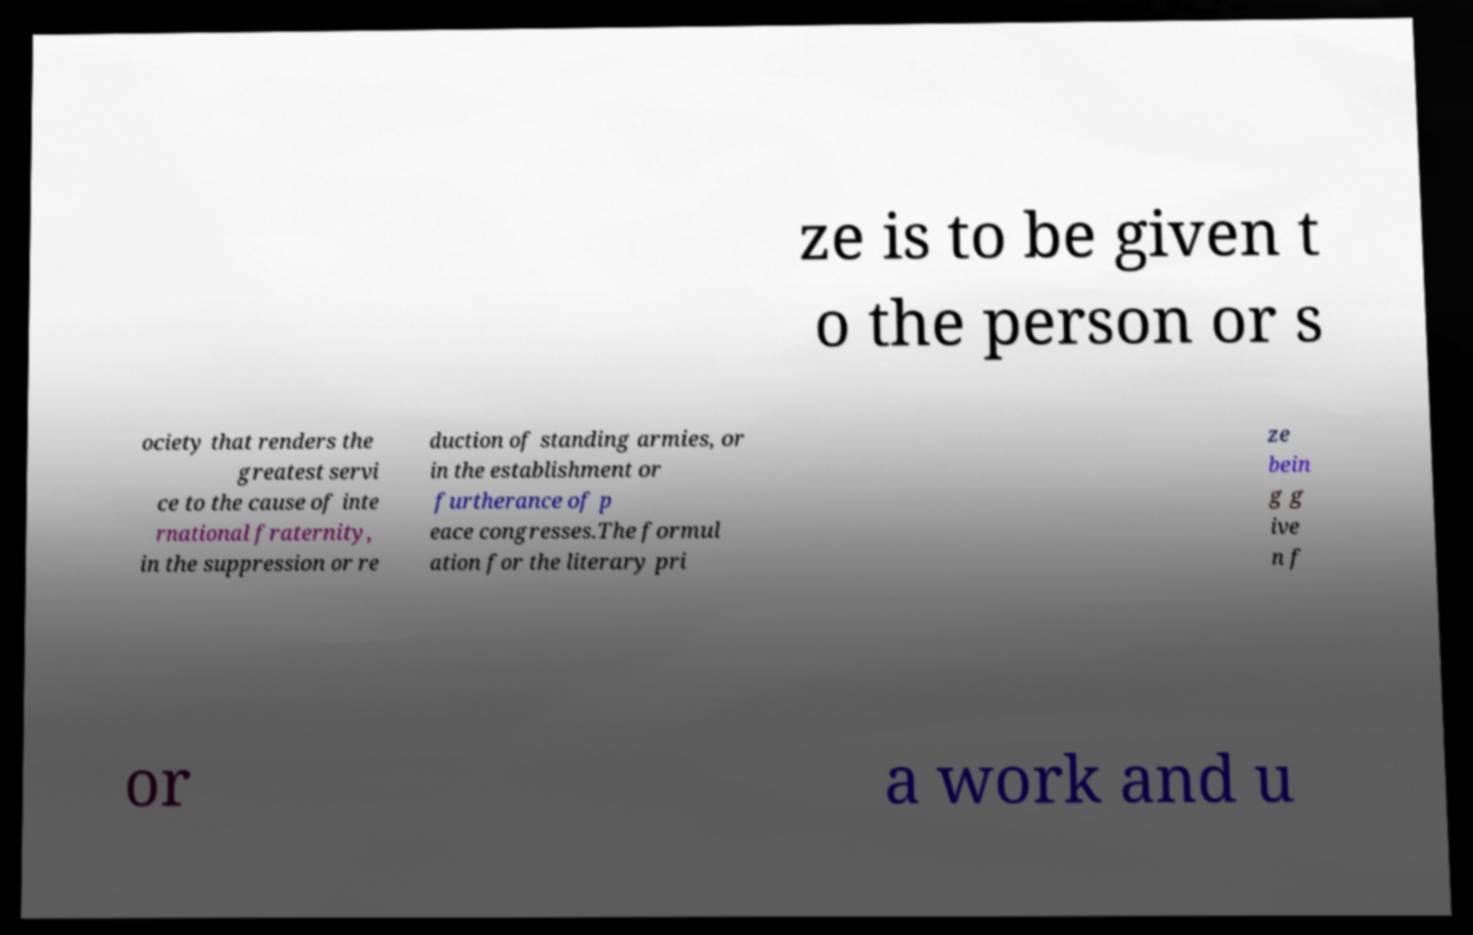Please identify and transcribe the text found in this image. ze is to be given t o the person or s ociety that renders the greatest servi ce to the cause of inte rnational fraternity, in the suppression or re duction of standing armies, or in the establishment or furtherance of p eace congresses.The formul ation for the literary pri ze bein g g ive n f or a work and u 